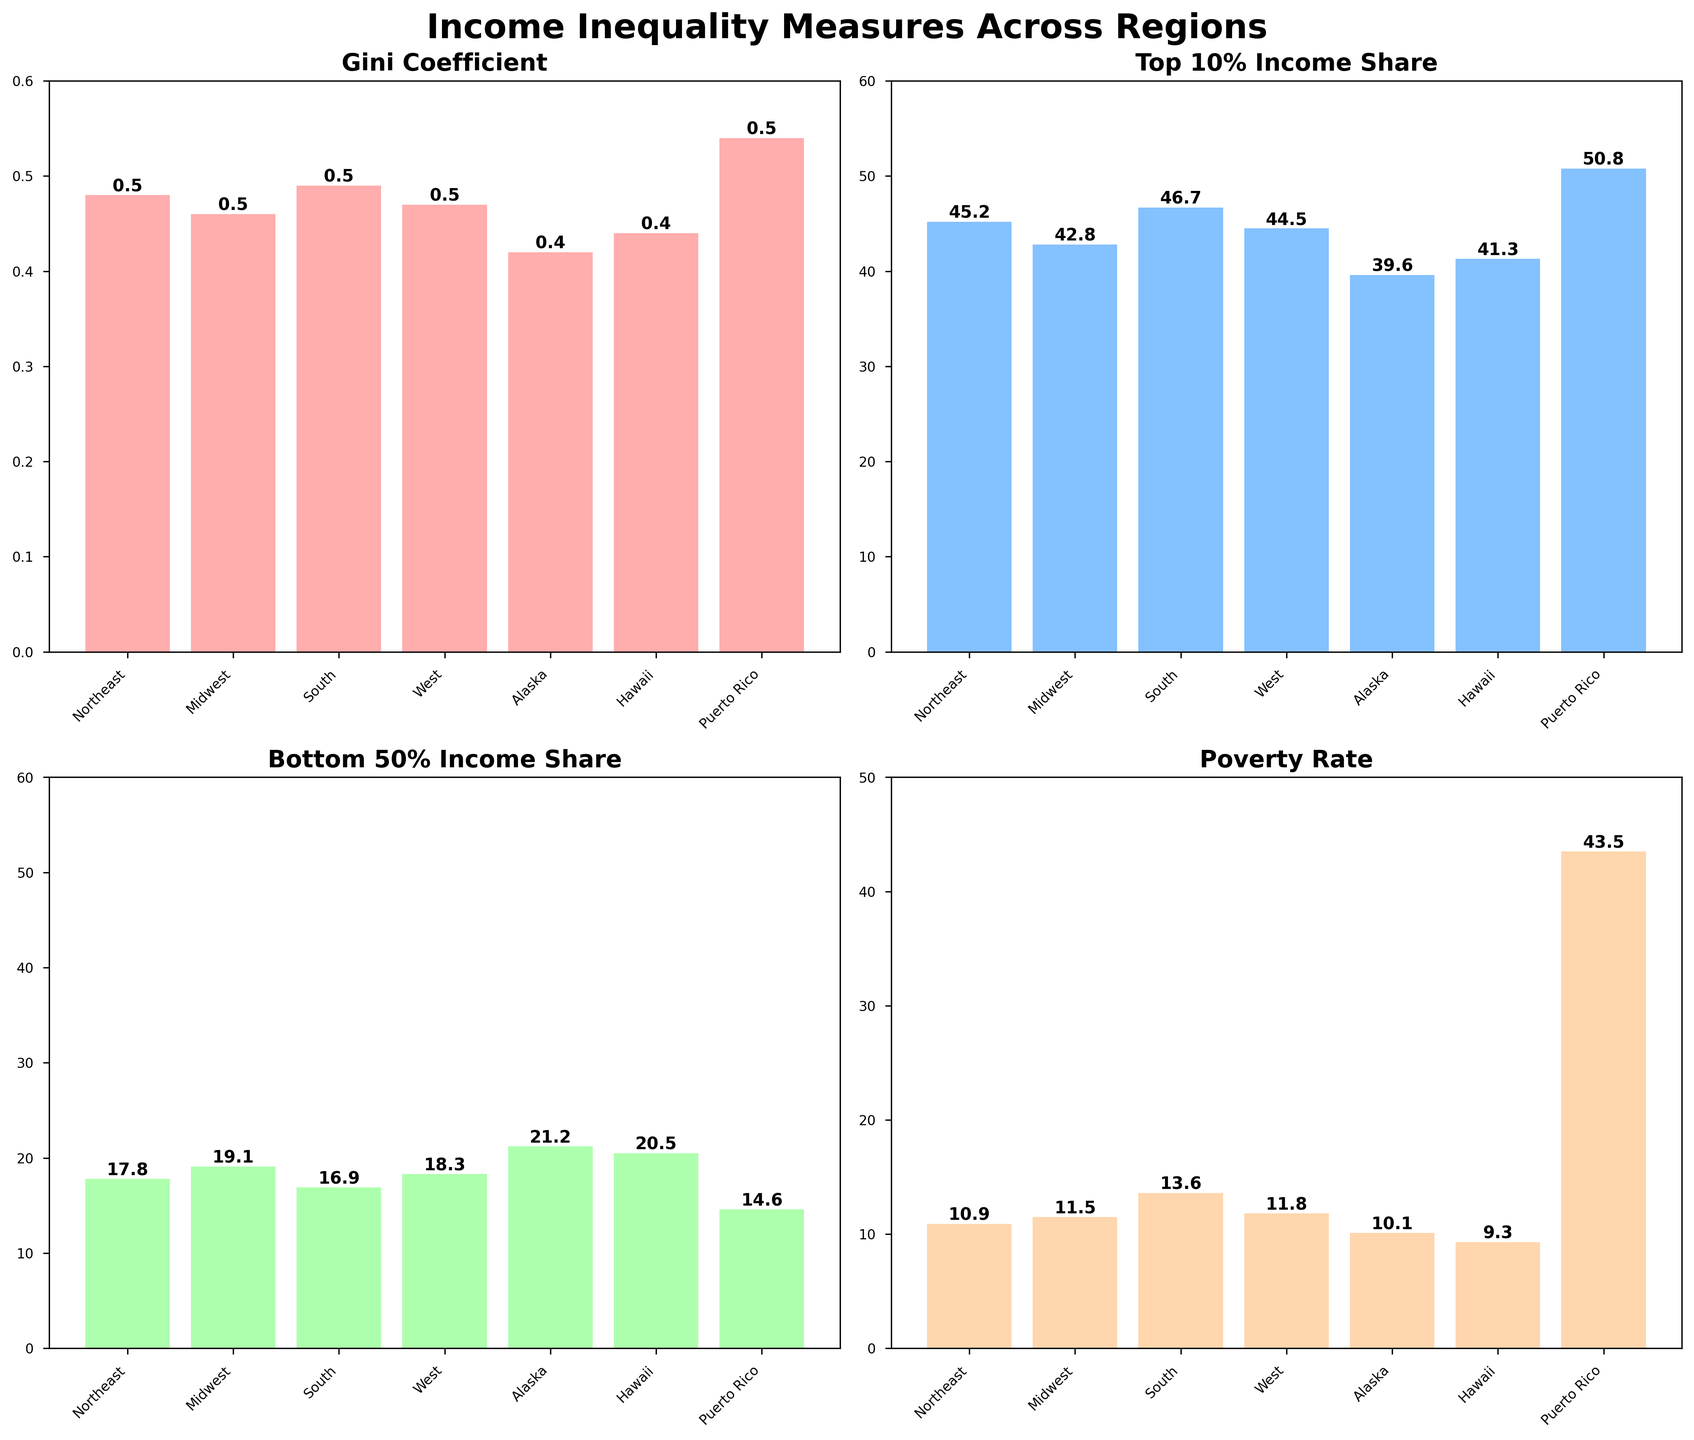Which region has the highest Gini Coefficient? The Gini Coefficient for each region is shown in the top left subplot. By comparing the heights of the bars, Puerto Rico has the highest Gini Coefficient.
Answer: Puerto Rico Which region has the highest poverty rate? The poverty rates are displayed in the bottom right subplot. The bar representing Puerto Rico is the tallest, indicating it has the highest poverty rate.
Answer: Puerto Rico How does the Gini Coefficient of the Midwest compare to that of the South? The Gini Coefficient for the Midwest is 0.46, and for the South, it is 0.49. By comparing these, the Gini Coefficient of the South is higher than that of the Midwest.
Answer: The South is higher Which region has the lowest Top 10% Income Share? The Top 10% Income Share is shown in the top right subplot. The smallest bar belongs to Alaska, indicating it has the lowest share.
Answer: Alaska What is the Top 10% Income Share for Hawaii? The Top 10% Income Share for Hawaii is displayed as a bar in the top right subplot. The value given for Hawaii is 41.3.
Answer: 41.3 Compare the Bottom 50% Income Share of Alaska and Puerto Rico. The Bottom 50% Income Share is shown in the bottom left subplot. Alaska has a share of 21.2, whereas Puerto Rico has a share of 14.6. So, Alaska’s share is higher.
Answer: Alaska is higher Which region has the smallest gap between the Top 10% Income Share and the Bottom 50% Income Share? The gap can be found by subtracting the Bottom 50% Income Share from the Top 10% Income Share for each region. The region with the smallest difference is identified by performing these calculations and comparing the results.
Answer: Hawaii List the regions in descending order of their poverty rates. By examining the bottom right subplot and arranging the heights of the bars from tallest to shortest, the order is Puerto Rico, South, Midwest, West, Northeast, Alaska, Hawaii.
Answer: Puerto Rico, South, Midwest, West, Northeast, Alaska, Hawaii What is the difference in Poverty Rate between the Northeast and the South? From the bottom right subplot, the Poverty Rate for the Northeast is 10.9 and for the South is 13.6. Subtracting 10.9 from 13.6 yields the difference.
Answer: 2.7 Is there any region with a Gini Coefficient lower than 0.45? By observing the top left subplot, only Alaska (0.42) and Hawaii (0.44) have a Gini Coefficient lower than 0.45.
Answer: Alaska and Hawaii 